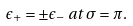Convert formula to latex. <formula><loc_0><loc_0><loc_500><loc_500>\epsilon _ { + } = \pm \epsilon _ { - } \, a t \, \sigma = \pi .</formula> 